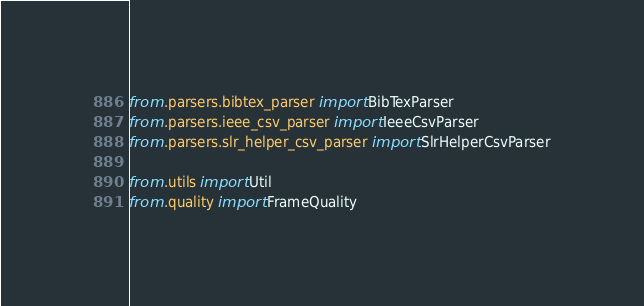<code> <loc_0><loc_0><loc_500><loc_500><_Python_>from .parsers.bibtex_parser import BibTexParser
from .parsers.ieee_csv_parser import IeeeCsvParser
from .parsers.slr_helper_csv_parser import SlrHelperCsvParser

from .utils import Util
from .quality import FrameQuality
</code> 